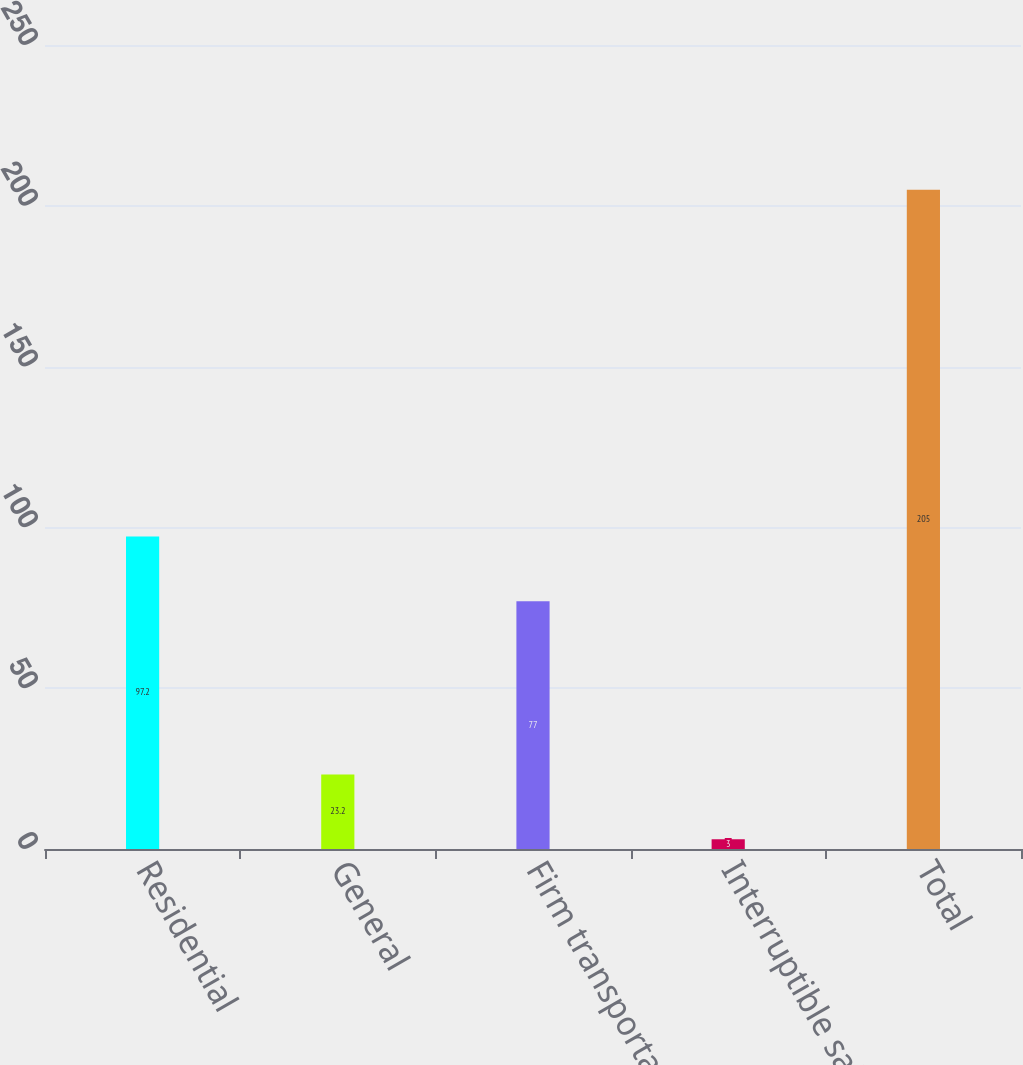<chart> <loc_0><loc_0><loc_500><loc_500><bar_chart><fcel>Residential<fcel>General<fcel>Firm transportation<fcel>Interruptible sales<fcel>Total<nl><fcel>97.2<fcel>23.2<fcel>77<fcel>3<fcel>205<nl></chart> 